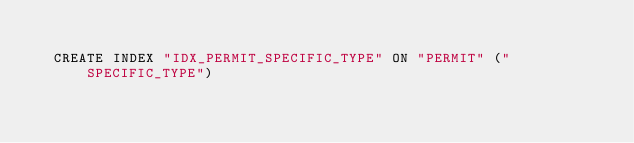<code> <loc_0><loc_0><loc_500><loc_500><_SQL_>
  CREATE INDEX "IDX_PERMIT_SPECIFIC_TYPE" ON "PERMIT" ("SPECIFIC_TYPE") 
  </code> 